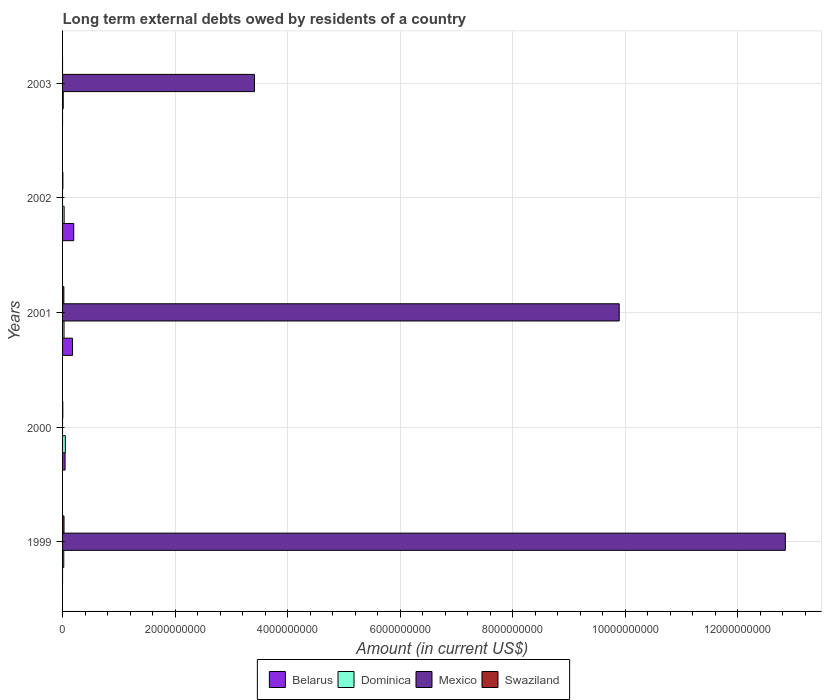How many groups of bars are there?
Provide a short and direct response. 5. Across all years, what is the maximum amount of long-term external debts owed by residents in Belarus?
Provide a short and direct response. 1.99e+08. In which year was the amount of long-term external debts owed by residents in Belarus maximum?
Keep it short and to the point. 2002. What is the total amount of long-term external debts owed by residents in Swaziland in the graph?
Offer a terse response. 5.74e+07. What is the difference between the amount of long-term external debts owed by residents in Swaziland in 1999 and that in 2000?
Your answer should be compact. 2.23e+07. What is the difference between the amount of long-term external debts owed by residents in Swaziland in 2000 and the amount of long-term external debts owed by residents in Mexico in 2003?
Offer a very short reply. -3.41e+09. What is the average amount of long-term external debts owed by residents in Swaziland per year?
Make the answer very short. 1.15e+07. In the year 2000, what is the difference between the amount of long-term external debts owed by residents in Swaziland and amount of long-term external debts owed by residents in Belarus?
Keep it short and to the point. -4.10e+07. What is the ratio of the amount of long-term external debts owed by residents in Mexico in 1999 to that in 2001?
Provide a short and direct response. 1.3. Is the amount of long-term external debts owed by residents in Dominica in 2002 less than that in 2003?
Your answer should be very brief. No. What is the difference between the highest and the second highest amount of long-term external debts owed by residents in Dominica?
Your answer should be compact. 2.15e+07. What is the difference between the highest and the lowest amount of long-term external debts owed by residents in Swaziland?
Provide a short and direct response. 2.57e+07. Is it the case that in every year, the sum of the amount of long-term external debts owed by residents in Dominica and amount of long-term external debts owed by residents in Mexico is greater than the sum of amount of long-term external debts owed by residents in Swaziland and amount of long-term external debts owed by residents in Belarus?
Make the answer very short. No. Is it the case that in every year, the sum of the amount of long-term external debts owed by residents in Belarus and amount of long-term external debts owed by residents in Swaziland is greater than the amount of long-term external debts owed by residents in Dominica?
Make the answer very short. No. How many bars are there?
Make the answer very short. 15. How many years are there in the graph?
Ensure brevity in your answer.  5. Does the graph contain any zero values?
Give a very brief answer. Yes. Where does the legend appear in the graph?
Offer a terse response. Bottom center. What is the title of the graph?
Provide a succinct answer. Long term external debts owed by residents of a country. What is the Amount (in current US$) in Belarus in 1999?
Provide a succinct answer. 0. What is the Amount (in current US$) of Dominica in 1999?
Keep it short and to the point. 2.12e+07. What is the Amount (in current US$) of Mexico in 1999?
Your answer should be compact. 1.28e+1. What is the Amount (in current US$) of Swaziland in 1999?
Your answer should be very brief. 2.57e+07. What is the Amount (in current US$) of Belarus in 2000?
Offer a terse response. 4.45e+07. What is the Amount (in current US$) of Dominica in 2000?
Make the answer very short. 4.93e+07. What is the Amount (in current US$) of Mexico in 2000?
Ensure brevity in your answer.  0. What is the Amount (in current US$) in Swaziland in 2000?
Ensure brevity in your answer.  3.44e+06. What is the Amount (in current US$) of Belarus in 2001?
Your response must be concise. 1.77e+08. What is the Amount (in current US$) in Dominica in 2001?
Ensure brevity in your answer.  2.59e+07. What is the Amount (in current US$) in Mexico in 2001?
Ensure brevity in your answer.  9.89e+09. What is the Amount (in current US$) of Swaziland in 2001?
Ensure brevity in your answer.  2.30e+07. What is the Amount (in current US$) of Belarus in 2002?
Keep it short and to the point. 1.99e+08. What is the Amount (in current US$) of Dominica in 2002?
Offer a terse response. 2.79e+07. What is the Amount (in current US$) of Mexico in 2002?
Your answer should be very brief. 0. What is the Amount (in current US$) of Swaziland in 2002?
Offer a very short reply. 5.19e+06. What is the Amount (in current US$) in Dominica in 2003?
Ensure brevity in your answer.  1.23e+07. What is the Amount (in current US$) of Mexico in 2003?
Offer a terse response. 3.41e+09. Across all years, what is the maximum Amount (in current US$) of Belarus?
Your response must be concise. 1.99e+08. Across all years, what is the maximum Amount (in current US$) of Dominica?
Your response must be concise. 4.93e+07. Across all years, what is the maximum Amount (in current US$) in Mexico?
Your answer should be very brief. 1.28e+1. Across all years, what is the maximum Amount (in current US$) of Swaziland?
Your response must be concise. 2.57e+07. Across all years, what is the minimum Amount (in current US$) in Dominica?
Your answer should be compact. 1.23e+07. Across all years, what is the minimum Amount (in current US$) of Mexico?
Offer a terse response. 0. Across all years, what is the minimum Amount (in current US$) in Swaziland?
Your answer should be compact. 0. What is the total Amount (in current US$) of Belarus in the graph?
Give a very brief answer. 4.20e+08. What is the total Amount (in current US$) of Dominica in the graph?
Offer a terse response. 1.37e+08. What is the total Amount (in current US$) in Mexico in the graph?
Your response must be concise. 2.61e+1. What is the total Amount (in current US$) of Swaziland in the graph?
Ensure brevity in your answer.  5.74e+07. What is the difference between the Amount (in current US$) of Dominica in 1999 and that in 2000?
Make the answer very short. -2.81e+07. What is the difference between the Amount (in current US$) of Swaziland in 1999 and that in 2000?
Keep it short and to the point. 2.23e+07. What is the difference between the Amount (in current US$) in Dominica in 1999 and that in 2001?
Give a very brief answer. -4.68e+06. What is the difference between the Amount (in current US$) of Mexico in 1999 and that in 2001?
Give a very brief answer. 2.95e+09. What is the difference between the Amount (in current US$) of Swaziland in 1999 and that in 2001?
Provide a succinct answer. 2.69e+06. What is the difference between the Amount (in current US$) in Dominica in 1999 and that in 2002?
Your response must be concise. -6.64e+06. What is the difference between the Amount (in current US$) in Swaziland in 1999 and that in 2002?
Your response must be concise. 2.06e+07. What is the difference between the Amount (in current US$) in Dominica in 1999 and that in 2003?
Your answer should be compact. 8.96e+06. What is the difference between the Amount (in current US$) in Mexico in 1999 and that in 2003?
Your answer should be very brief. 9.43e+09. What is the difference between the Amount (in current US$) of Belarus in 2000 and that in 2001?
Keep it short and to the point. -1.33e+08. What is the difference between the Amount (in current US$) of Dominica in 2000 and that in 2001?
Your answer should be very brief. 2.34e+07. What is the difference between the Amount (in current US$) of Swaziland in 2000 and that in 2001?
Offer a terse response. -1.96e+07. What is the difference between the Amount (in current US$) of Belarus in 2000 and that in 2002?
Your answer should be very brief. -1.54e+08. What is the difference between the Amount (in current US$) in Dominica in 2000 and that in 2002?
Your response must be concise. 2.15e+07. What is the difference between the Amount (in current US$) of Swaziland in 2000 and that in 2002?
Keep it short and to the point. -1.75e+06. What is the difference between the Amount (in current US$) in Dominica in 2000 and that in 2003?
Keep it short and to the point. 3.71e+07. What is the difference between the Amount (in current US$) in Belarus in 2001 and that in 2002?
Your response must be concise. -2.11e+07. What is the difference between the Amount (in current US$) of Dominica in 2001 and that in 2002?
Your answer should be compact. -1.96e+06. What is the difference between the Amount (in current US$) of Swaziland in 2001 and that in 2002?
Your answer should be compact. 1.79e+07. What is the difference between the Amount (in current US$) of Dominica in 2001 and that in 2003?
Offer a terse response. 1.36e+07. What is the difference between the Amount (in current US$) in Mexico in 2001 and that in 2003?
Ensure brevity in your answer.  6.48e+09. What is the difference between the Amount (in current US$) in Dominica in 2002 and that in 2003?
Your answer should be very brief. 1.56e+07. What is the difference between the Amount (in current US$) in Dominica in 1999 and the Amount (in current US$) in Swaziland in 2000?
Make the answer very short. 1.78e+07. What is the difference between the Amount (in current US$) in Mexico in 1999 and the Amount (in current US$) in Swaziland in 2000?
Your answer should be compact. 1.28e+1. What is the difference between the Amount (in current US$) of Dominica in 1999 and the Amount (in current US$) of Mexico in 2001?
Provide a short and direct response. -9.87e+09. What is the difference between the Amount (in current US$) in Dominica in 1999 and the Amount (in current US$) in Swaziland in 2001?
Ensure brevity in your answer.  -1.82e+06. What is the difference between the Amount (in current US$) in Mexico in 1999 and the Amount (in current US$) in Swaziland in 2001?
Your answer should be compact. 1.28e+1. What is the difference between the Amount (in current US$) in Dominica in 1999 and the Amount (in current US$) in Swaziland in 2002?
Your answer should be very brief. 1.60e+07. What is the difference between the Amount (in current US$) in Mexico in 1999 and the Amount (in current US$) in Swaziland in 2002?
Ensure brevity in your answer.  1.28e+1. What is the difference between the Amount (in current US$) in Dominica in 1999 and the Amount (in current US$) in Mexico in 2003?
Offer a very short reply. -3.39e+09. What is the difference between the Amount (in current US$) of Belarus in 2000 and the Amount (in current US$) of Dominica in 2001?
Offer a very short reply. 1.85e+07. What is the difference between the Amount (in current US$) in Belarus in 2000 and the Amount (in current US$) in Mexico in 2001?
Your answer should be very brief. -9.85e+09. What is the difference between the Amount (in current US$) of Belarus in 2000 and the Amount (in current US$) of Swaziland in 2001?
Provide a succinct answer. 2.14e+07. What is the difference between the Amount (in current US$) of Dominica in 2000 and the Amount (in current US$) of Mexico in 2001?
Provide a short and direct response. -9.84e+09. What is the difference between the Amount (in current US$) of Dominica in 2000 and the Amount (in current US$) of Swaziland in 2001?
Make the answer very short. 2.63e+07. What is the difference between the Amount (in current US$) of Belarus in 2000 and the Amount (in current US$) of Dominica in 2002?
Keep it short and to the point. 1.66e+07. What is the difference between the Amount (in current US$) of Belarus in 2000 and the Amount (in current US$) of Swaziland in 2002?
Your response must be concise. 3.93e+07. What is the difference between the Amount (in current US$) in Dominica in 2000 and the Amount (in current US$) in Swaziland in 2002?
Your response must be concise. 4.42e+07. What is the difference between the Amount (in current US$) in Belarus in 2000 and the Amount (in current US$) in Dominica in 2003?
Keep it short and to the point. 3.22e+07. What is the difference between the Amount (in current US$) of Belarus in 2000 and the Amount (in current US$) of Mexico in 2003?
Ensure brevity in your answer.  -3.37e+09. What is the difference between the Amount (in current US$) of Dominica in 2000 and the Amount (in current US$) of Mexico in 2003?
Your answer should be compact. -3.36e+09. What is the difference between the Amount (in current US$) in Belarus in 2001 and the Amount (in current US$) in Dominica in 2002?
Keep it short and to the point. 1.50e+08. What is the difference between the Amount (in current US$) of Belarus in 2001 and the Amount (in current US$) of Swaziland in 2002?
Ensure brevity in your answer.  1.72e+08. What is the difference between the Amount (in current US$) in Dominica in 2001 and the Amount (in current US$) in Swaziland in 2002?
Your response must be concise. 2.07e+07. What is the difference between the Amount (in current US$) in Mexico in 2001 and the Amount (in current US$) in Swaziland in 2002?
Ensure brevity in your answer.  9.89e+09. What is the difference between the Amount (in current US$) in Belarus in 2001 and the Amount (in current US$) in Dominica in 2003?
Your answer should be compact. 1.65e+08. What is the difference between the Amount (in current US$) of Belarus in 2001 and the Amount (in current US$) of Mexico in 2003?
Keep it short and to the point. -3.23e+09. What is the difference between the Amount (in current US$) in Dominica in 2001 and the Amount (in current US$) in Mexico in 2003?
Give a very brief answer. -3.38e+09. What is the difference between the Amount (in current US$) of Belarus in 2002 and the Amount (in current US$) of Dominica in 2003?
Your answer should be compact. 1.86e+08. What is the difference between the Amount (in current US$) in Belarus in 2002 and the Amount (in current US$) in Mexico in 2003?
Make the answer very short. -3.21e+09. What is the difference between the Amount (in current US$) of Dominica in 2002 and the Amount (in current US$) of Mexico in 2003?
Make the answer very short. -3.38e+09. What is the average Amount (in current US$) in Belarus per year?
Give a very brief answer. 8.41e+07. What is the average Amount (in current US$) of Dominica per year?
Provide a succinct answer. 2.73e+07. What is the average Amount (in current US$) of Mexico per year?
Provide a succinct answer. 5.23e+09. What is the average Amount (in current US$) in Swaziland per year?
Make the answer very short. 1.15e+07. In the year 1999, what is the difference between the Amount (in current US$) of Dominica and Amount (in current US$) of Mexico?
Provide a short and direct response. -1.28e+1. In the year 1999, what is the difference between the Amount (in current US$) of Dominica and Amount (in current US$) of Swaziland?
Provide a short and direct response. -4.51e+06. In the year 1999, what is the difference between the Amount (in current US$) in Mexico and Amount (in current US$) in Swaziland?
Give a very brief answer. 1.28e+1. In the year 2000, what is the difference between the Amount (in current US$) of Belarus and Amount (in current US$) of Dominica?
Keep it short and to the point. -4.88e+06. In the year 2000, what is the difference between the Amount (in current US$) of Belarus and Amount (in current US$) of Swaziland?
Keep it short and to the point. 4.10e+07. In the year 2000, what is the difference between the Amount (in current US$) of Dominica and Amount (in current US$) of Swaziland?
Provide a succinct answer. 4.59e+07. In the year 2001, what is the difference between the Amount (in current US$) in Belarus and Amount (in current US$) in Dominica?
Your response must be concise. 1.52e+08. In the year 2001, what is the difference between the Amount (in current US$) of Belarus and Amount (in current US$) of Mexico?
Provide a succinct answer. -9.71e+09. In the year 2001, what is the difference between the Amount (in current US$) of Belarus and Amount (in current US$) of Swaziland?
Keep it short and to the point. 1.54e+08. In the year 2001, what is the difference between the Amount (in current US$) in Dominica and Amount (in current US$) in Mexico?
Keep it short and to the point. -9.87e+09. In the year 2001, what is the difference between the Amount (in current US$) in Dominica and Amount (in current US$) in Swaziland?
Ensure brevity in your answer.  2.86e+06. In the year 2001, what is the difference between the Amount (in current US$) in Mexico and Amount (in current US$) in Swaziland?
Keep it short and to the point. 9.87e+09. In the year 2002, what is the difference between the Amount (in current US$) in Belarus and Amount (in current US$) in Dominica?
Provide a succinct answer. 1.71e+08. In the year 2002, what is the difference between the Amount (in current US$) in Belarus and Amount (in current US$) in Swaziland?
Keep it short and to the point. 1.93e+08. In the year 2002, what is the difference between the Amount (in current US$) in Dominica and Amount (in current US$) in Swaziland?
Your response must be concise. 2.27e+07. In the year 2003, what is the difference between the Amount (in current US$) in Dominica and Amount (in current US$) in Mexico?
Your answer should be very brief. -3.40e+09. What is the ratio of the Amount (in current US$) of Dominica in 1999 to that in 2000?
Make the answer very short. 0.43. What is the ratio of the Amount (in current US$) of Swaziland in 1999 to that in 2000?
Your answer should be compact. 7.49. What is the ratio of the Amount (in current US$) in Dominica in 1999 to that in 2001?
Offer a very short reply. 0.82. What is the ratio of the Amount (in current US$) of Mexico in 1999 to that in 2001?
Provide a succinct answer. 1.3. What is the ratio of the Amount (in current US$) of Swaziland in 1999 to that in 2001?
Offer a terse response. 1.12. What is the ratio of the Amount (in current US$) in Dominica in 1999 to that in 2002?
Your answer should be compact. 0.76. What is the ratio of the Amount (in current US$) in Swaziland in 1999 to that in 2002?
Keep it short and to the point. 4.96. What is the ratio of the Amount (in current US$) of Dominica in 1999 to that in 2003?
Your answer should be compact. 1.73. What is the ratio of the Amount (in current US$) in Mexico in 1999 to that in 2003?
Offer a terse response. 3.77. What is the ratio of the Amount (in current US$) of Belarus in 2000 to that in 2001?
Your response must be concise. 0.25. What is the ratio of the Amount (in current US$) of Dominica in 2000 to that in 2001?
Offer a terse response. 1.9. What is the ratio of the Amount (in current US$) of Swaziland in 2000 to that in 2001?
Provide a succinct answer. 0.15. What is the ratio of the Amount (in current US$) in Belarus in 2000 to that in 2002?
Give a very brief answer. 0.22. What is the ratio of the Amount (in current US$) of Dominica in 2000 to that in 2002?
Give a very brief answer. 1.77. What is the ratio of the Amount (in current US$) in Swaziland in 2000 to that in 2002?
Your response must be concise. 0.66. What is the ratio of the Amount (in current US$) of Dominica in 2000 to that in 2003?
Your answer should be compact. 4.02. What is the ratio of the Amount (in current US$) of Belarus in 2001 to that in 2002?
Ensure brevity in your answer.  0.89. What is the ratio of the Amount (in current US$) in Dominica in 2001 to that in 2002?
Your answer should be very brief. 0.93. What is the ratio of the Amount (in current US$) of Swaziland in 2001 to that in 2002?
Make the answer very short. 4.44. What is the ratio of the Amount (in current US$) of Dominica in 2001 to that in 2003?
Your answer should be compact. 2.11. What is the ratio of the Amount (in current US$) in Mexico in 2001 to that in 2003?
Keep it short and to the point. 2.9. What is the ratio of the Amount (in current US$) of Dominica in 2002 to that in 2003?
Offer a very short reply. 2.27. What is the difference between the highest and the second highest Amount (in current US$) in Belarus?
Your answer should be very brief. 2.11e+07. What is the difference between the highest and the second highest Amount (in current US$) of Dominica?
Ensure brevity in your answer.  2.15e+07. What is the difference between the highest and the second highest Amount (in current US$) in Mexico?
Provide a succinct answer. 2.95e+09. What is the difference between the highest and the second highest Amount (in current US$) of Swaziland?
Offer a terse response. 2.69e+06. What is the difference between the highest and the lowest Amount (in current US$) in Belarus?
Provide a short and direct response. 1.99e+08. What is the difference between the highest and the lowest Amount (in current US$) in Dominica?
Ensure brevity in your answer.  3.71e+07. What is the difference between the highest and the lowest Amount (in current US$) of Mexico?
Your answer should be very brief. 1.28e+1. What is the difference between the highest and the lowest Amount (in current US$) in Swaziland?
Your answer should be compact. 2.57e+07. 